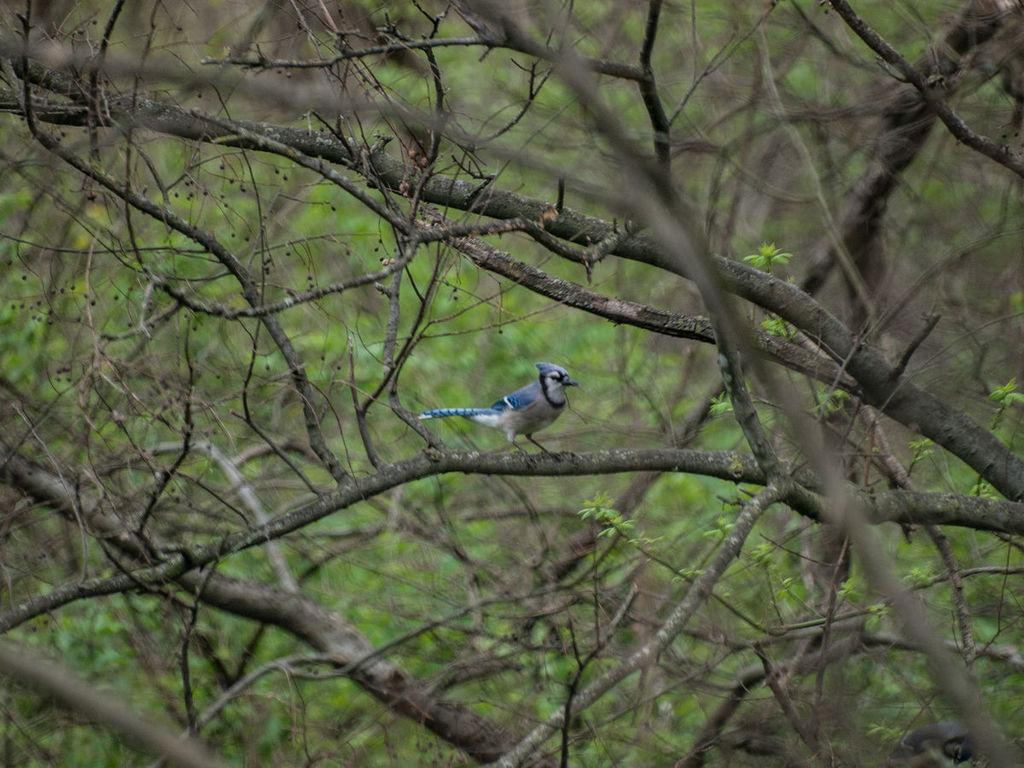What type of animal can be seen in the image? There is a bird in the image. Where is the bird located? The bird is sitting on a tree branch. Can you describe the condition of the tree branch? The tree branch appears to be dry. What is the appearance of the background in the image? The background of the image is blurred. What color is the grape that the bird is holding in the image? There is no grape present in the image, and the bird is not holding anything. 